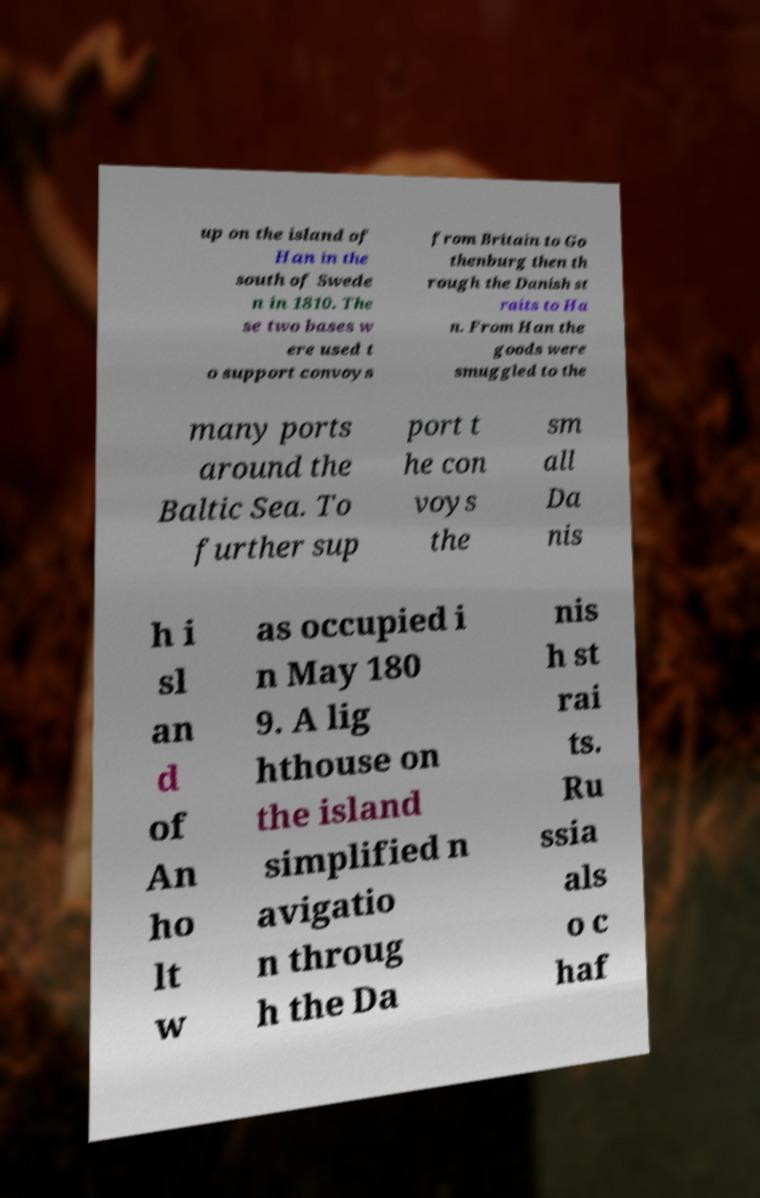What messages or text are displayed in this image? I need them in a readable, typed format. up on the island of Han in the south of Swede n in 1810. The se two bases w ere used t o support convoys from Britain to Go thenburg then th rough the Danish st raits to Ha n. From Han the goods were smuggled to the many ports around the Baltic Sea. To further sup port t he con voys the sm all Da nis h i sl an d of An ho lt w as occupied i n May 180 9. A lig hthouse on the island simplified n avigatio n throug h the Da nis h st rai ts. Ru ssia als o c haf 